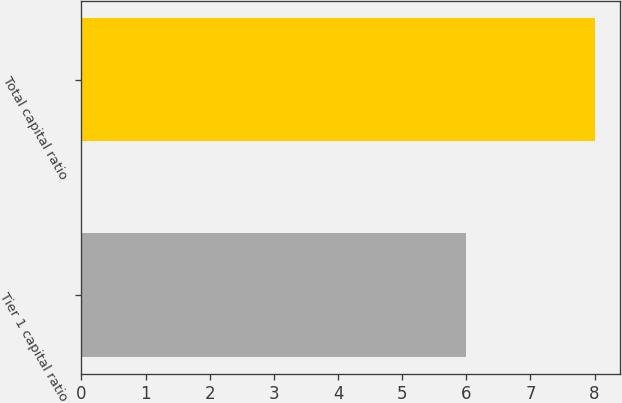<chart> <loc_0><loc_0><loc_500><loc_500><bar_chart><fcel>Tier 1 capital ratio<fcel>Total capital ratio<nl><fcel>6<fcel>8<nl></chart> 